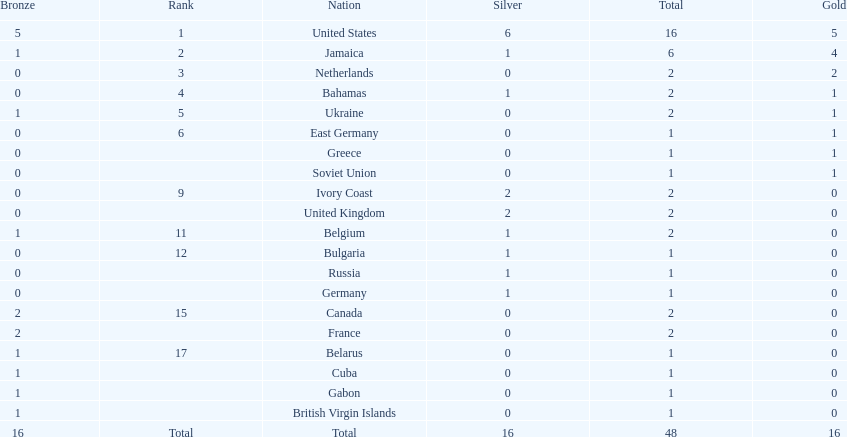How many countries had zero gold medals won? 12. 